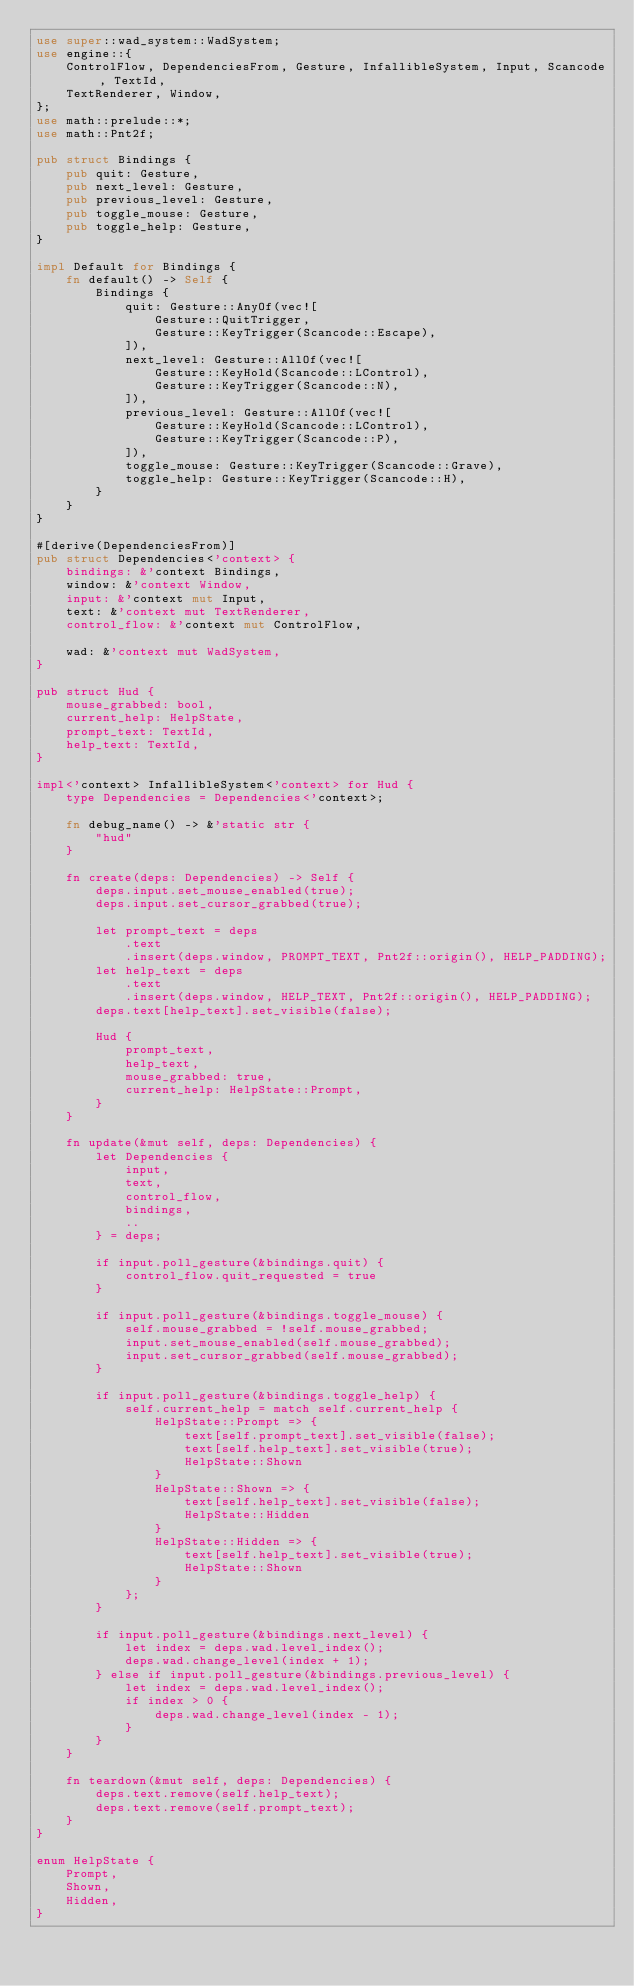Convert code to text. <code><loc_0><loc_0><loc_500><loc_500><_Rust_>use super::wad_system::WadSystem;
use engine::{
    ControlFlow, DependenciesFrom, Gesture, InfallibleSystem, Input, Scancode, TextId,
    TextRenderer, Window,
};
use math::prelude::*;
use math::Pnt2f;

pub struct Bindings {
    pub quit: Gesture,
    pub next_level: Gesture,
    pub previous_level: Gesture,
    pub toggle_mouse: Gesture,
    pub toggle_help: Gesture,
}

impl Default for Bindings {
    fn default() -> Self {
        Bindings {
            quit: Gesture::AnyOf(vec![
                Gesture::QuitTrigger,
                Gesture::KeyTrigger(Scancode::Escape),
            ]),
            next_level: Gesture::AllOf(vec![
                Gesture::KeyHold(Scancode::LControl),
                Gesture::KeyTrigger(Scancode::N),
            ]),
            previous_level: Gesture::AllOf(vec![
                Gesture::KeyHold(Scancode::LControl),
                Gesture::KeyTrigger(Scancode::P),
            ]),
            toggle_mouse: Gesture::KeyTrigger(Scancode::Grave),
            toggle_help: Gesture::KeyTrigger(Scancode::H),
        }
    }
}

#[derive(DependenciesFrom)]
pub struct Dependencies<'context> {
    bindings: &'context Bindings,
    window: &'context Window,
    input: &'context mut Input,
    text: &'context mut TextRenderer,
    control_flow: &'context mut ControlFlow,

    wad: &'context mut WadSystem,
}

pub struct Hud {
    mouse_grabbed: bool,
    current_help: HelpState,
    prompt_text: TextId,
    help_text: TextId,
}

impl<'context> InfallibleSystem<'context> for Hud {
    type Dependencies = Dependencies<'context>;

    fn debug_name() -> &'static str {
        "hud"
    }

    fn create(deps: Dependencies) -> Self {
        deps.input.set_mouse_enabled(true);
        deps.input.set_cursor_grabbed(true);

        let prompt_text = deps
            .text
            .insert(deps.window, PROMPT_TEXT, Pnt2f::origin(), HELP_PADDING);
        let help_text = deps
            .text
            .insert(deps.window, HELP_TEXT, Pnt2f::origin(), HELP_PADDING);
        deps.text[help_text].set_visible(false);

        Hud {
            prompt_text,
            help_text,
            mouse_grabbed: true,
            current_help: HelpState::Prompt,
        }
    }

    fn update(&mut self, deps: Dependencies) {
        let Dependencies {
            input,
            text,
            control_flow,
            bindings,
            ..
        } = deps;

        if input.poll_gesture(&bindings.quit) {
            control_flow.quit_requested = true
        }

        if input.poll_gesture(&bindings.toggle_mouse) {
            self.mouse_grabbed = !self.mouse_grabbed;
            input.set_mouse_enabled(self.mouse_grabbed);
            input.set_cursor_grabbed(self.mouse_grabbed);
        }

        if input.poll_gesture(&bindings.toggle_help) {
            self.current_help = match self.current_help {
                HelpState::Prompt => {
                    text[self.prompt_text].set_visible(false);
                    text[self.help_text].set_visible(true);
                    HelpState::Shown
                }
                HelpState::Shown => {
                    text[self.help_text].set_visible(false);
                    HelpState::Hidden
                }
                HelpState::Hidden => {
                    text[self.help_text].set_visible(true);
                    HelpState::Shown
                }
            };
        }

        if input.poll_gesture(&bindings.next_level) {
            let index = deps.wad.level_index();
            deps.wad.change_level(index + 1);
        } else if input.poll_gesture(&bindings.previous_level) {
            let index = deps.wad.level_index();
            if index > 0 {
                deps.wad.change_level(index - 1);
            }
        }
    }

    fn teardown(&mut self, deps: Dependencies) {
        deps.text.remove(self.help_text);
        deps.text.remove(self.prompt_text);
    }
}

enum HelpState {
    Prompt,
    Shown,
    Hidden,
}
</code> 